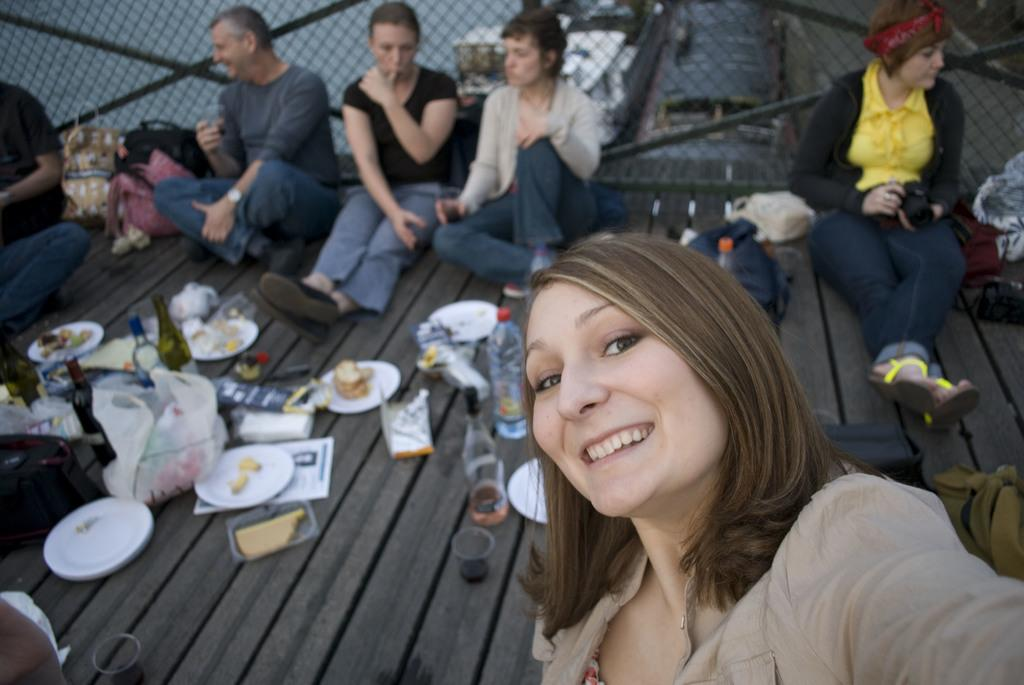What are the people in the image doing? The people in the image are sitting on the floor. What objects can be seen on the floor? There are bottles, plates, snacks, glasses, and tissue papers on the floor. What type of food is visible on the floor? There is food on the floor. What can be seen in the background of the image? There is a fence in the background of the image. What type of support does the grandmother provide in the image? There is no grandmother present in the image, so it is not possible to answer that question. 